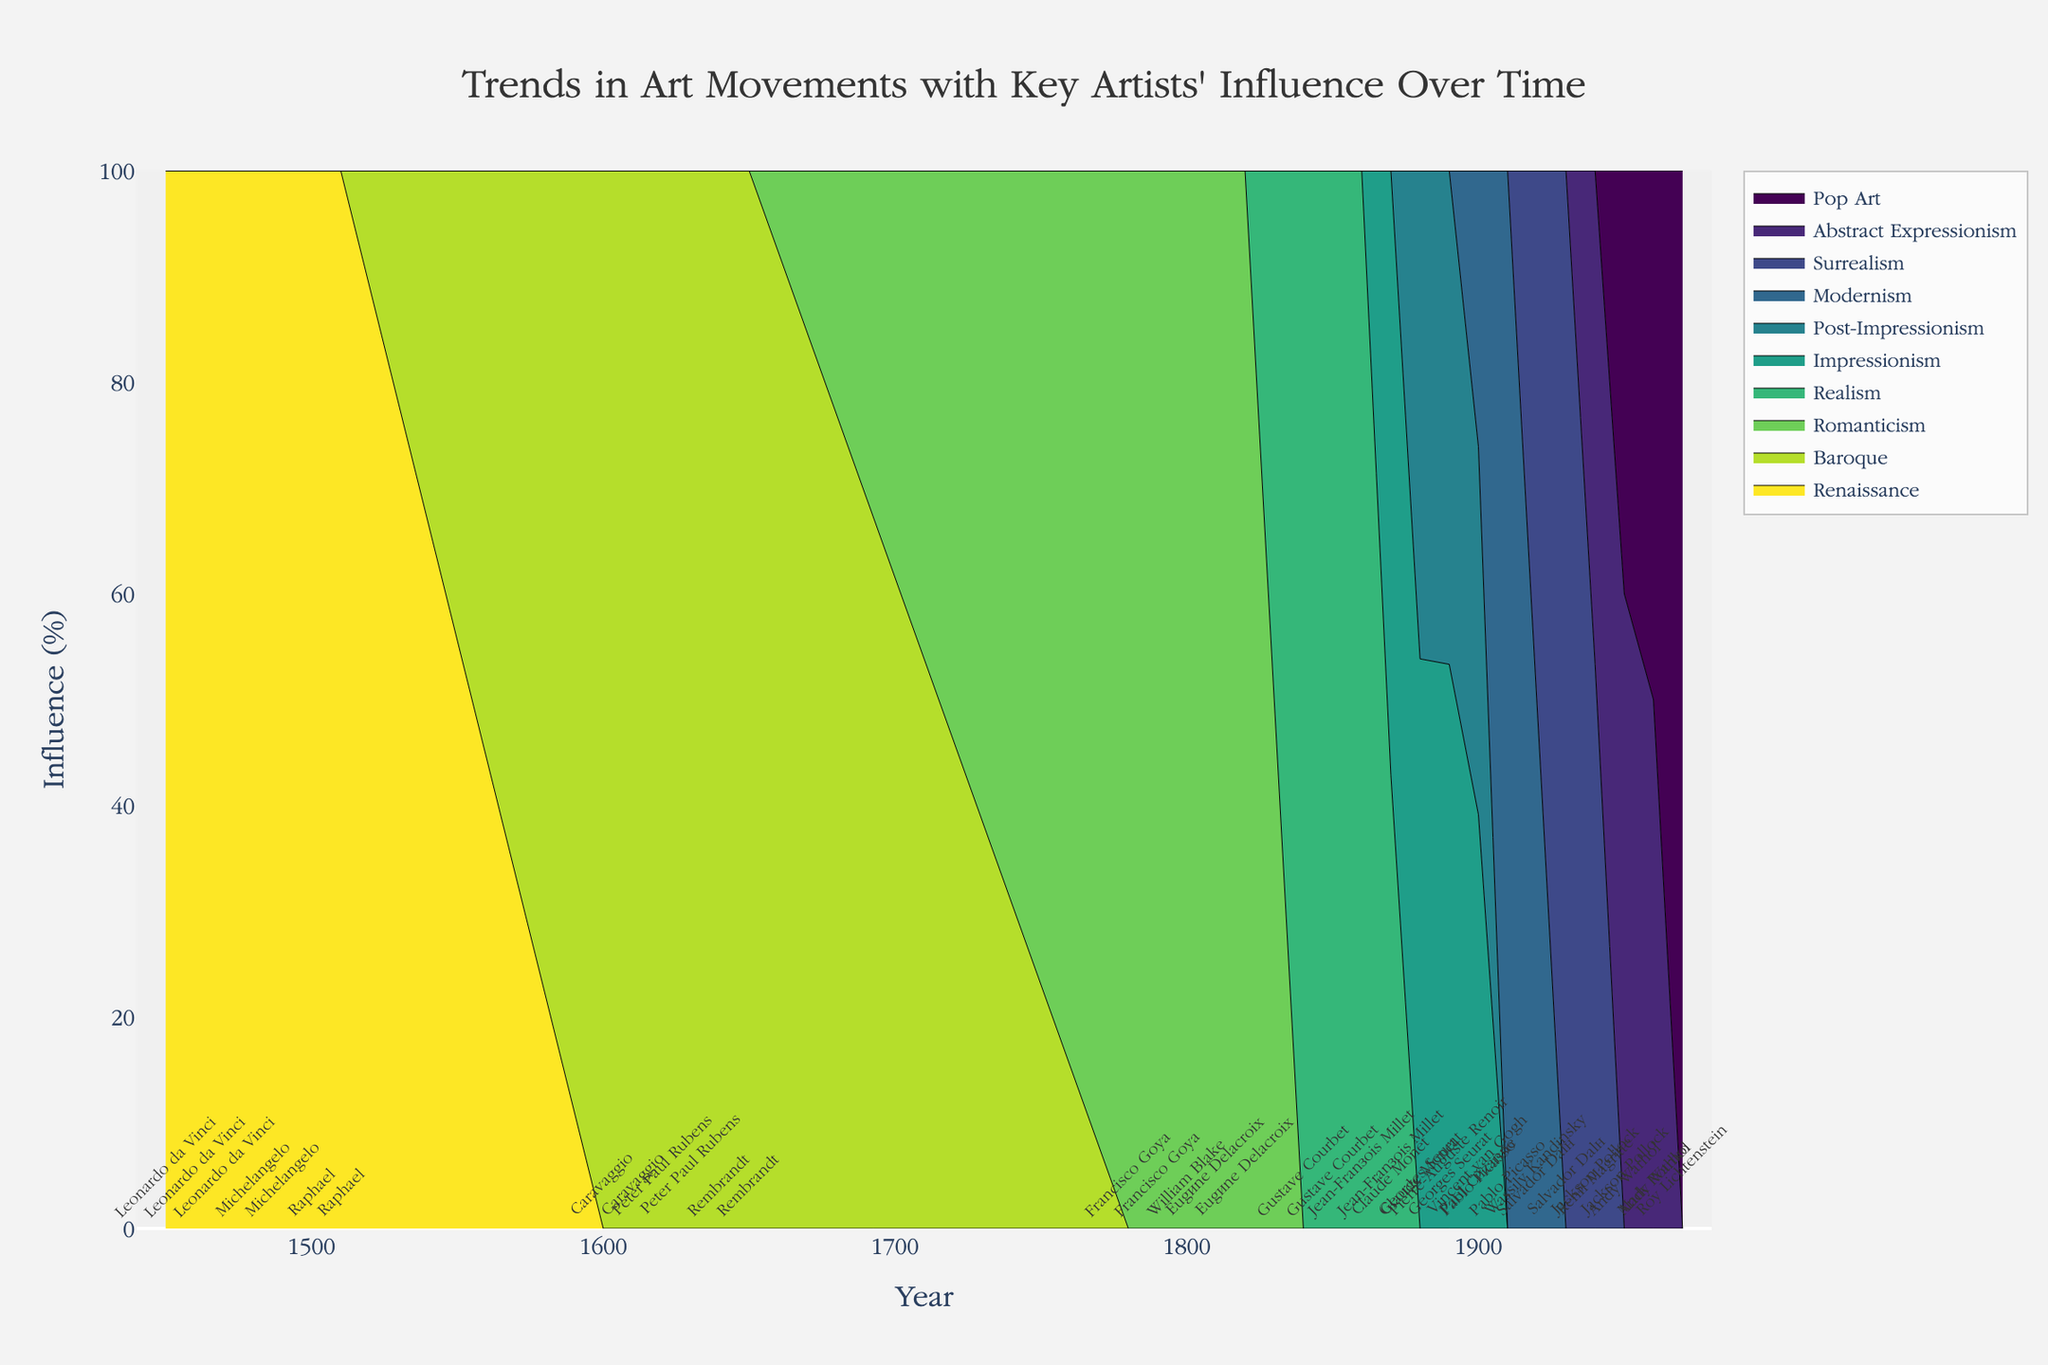What is the title of the figure? The title of the figure is typically placed at the top of the plot. It's written in a larger font size and designed to provide an overview of the data visualization.
Answer: Trends in Art Movements with Key Artists' Influence Over Time What is the maximum influence value for Leonardo da Vinci? By examining the section of the plot corresponding to Leonardo da Vinci within the Renaissance period (1450-1470), the peak influence value he achieved is observed.
Answer: 0.2 During which years does Michelangelo have a significant influence, and what is the peak value? Michelangelo's influence is visible within the Renaissance period. By looking at the plot, his significant years range from 1480 to 1490, with the peak influence occurring in 1490.
Answer: 1490, 0.3 Who was the key artist influencing the Baroque movement in 1620, and what was their influence value? In the Baroque section of the plot around the year 1620, the dominant artist's name and corresponding value can be identified.
Answer: Peter Paul Rubens, 0.4 How does the influence of Eugene Delacroix in the Romanticism movement change from 1810 to 1820? By focusing on Eugene Delacroix's contribution to Romanticism between 1810 and 1820 on the graph, we can track the influence values. His influence increases from 0.35 in 1810 to 0.4 in 1820.
Answer: Increases from 0.35 to 0.4 Compare the influence of Claude Monet and Vincent van Gogh within the Impressionism movement around 1900. By checking the part of the plot where both artists are represented within the Impressionism movement, Claude Monet's influence in 1900 is compared to Vincent van Gogh's influence in the same year. Monet's value is 0.35 in 1880 dropping to 0.4 in 1900, while van Gogh is peaking at 0.45 in 1900.
Answer: Vincent van Gogh has more influence in 1900 Which art movement had the highest influence value in 1950 and who was the artist responsible for it? By identifying the peak influence value in the year 1950 across all movements on the graph, and then noting the corresponding artist's name.
Answer: Jackson Pollock, Abstract Expressionism, 0.45 What trend in Modernism was set by Pablo Picasso from 1900 to 1910? By looking at the influence values for Pablo Picasso within the Modernism period from 1900 to 1910, we can observe the trend in his influence, which increases from 0.3 to 0.35.
Answer: Increasing trend How did the influence of Salvador Dalí change from 1920 to 1930 in the Surrealism movement? By examining the Surrealism movement on the graph, particularly observing Salvador Dalí's contribution, we see his influence increases from 0.4 in 1920 to 0.45 in 1930.
Answer: Increases What is the total influence of the Romanticism movement in the 1800s? Summing up the individual contributions of artists within the Romanticism movement throughout the 1800s (Francisco Goya, William Blake, Eugene Delacroix) as seen on the graph. Goya: 0.2+0.25, Blake: 0.3, Delacroix: 0.35+0.4 = 1.5
Answer: 1.5 